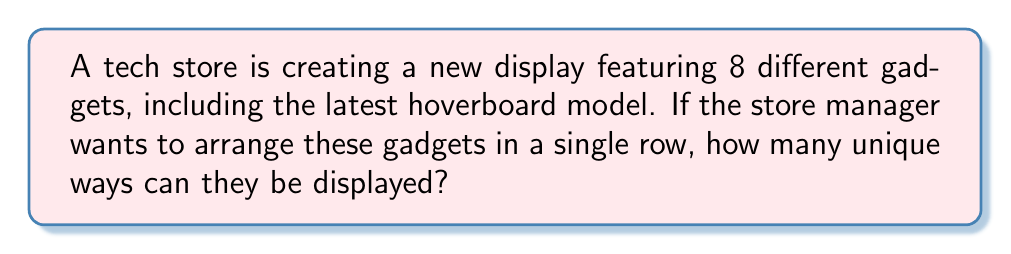Can you solve this math problem? Let's approach this step-by-step:

1) This problem is a straightforward permutation question. We need to arrange 8 distinct objects (gadgets) in a line.

2) In permutation problems where all objects are distinct and all are to be used, we use the formula:

   $$ P(n) = n! $$

   Where $n$ is the number of distinct objects.

3) In this case, $n = 8$ (the number of gadgets).

4) So, we need to calculate:

   $$ P(8) = 8! $$

5) Let's expand this:

   $$ 8! = 8 \times 7 \times 6 \times 5 \times 4 \times 3 \times 2 \times 1 $$

6) Computing this:

   $$ 8! = 40,320 $$

Therefore, there are 40,320 unique ways to arrange the 8 gadgets in the store display.
Answer: 40,320 